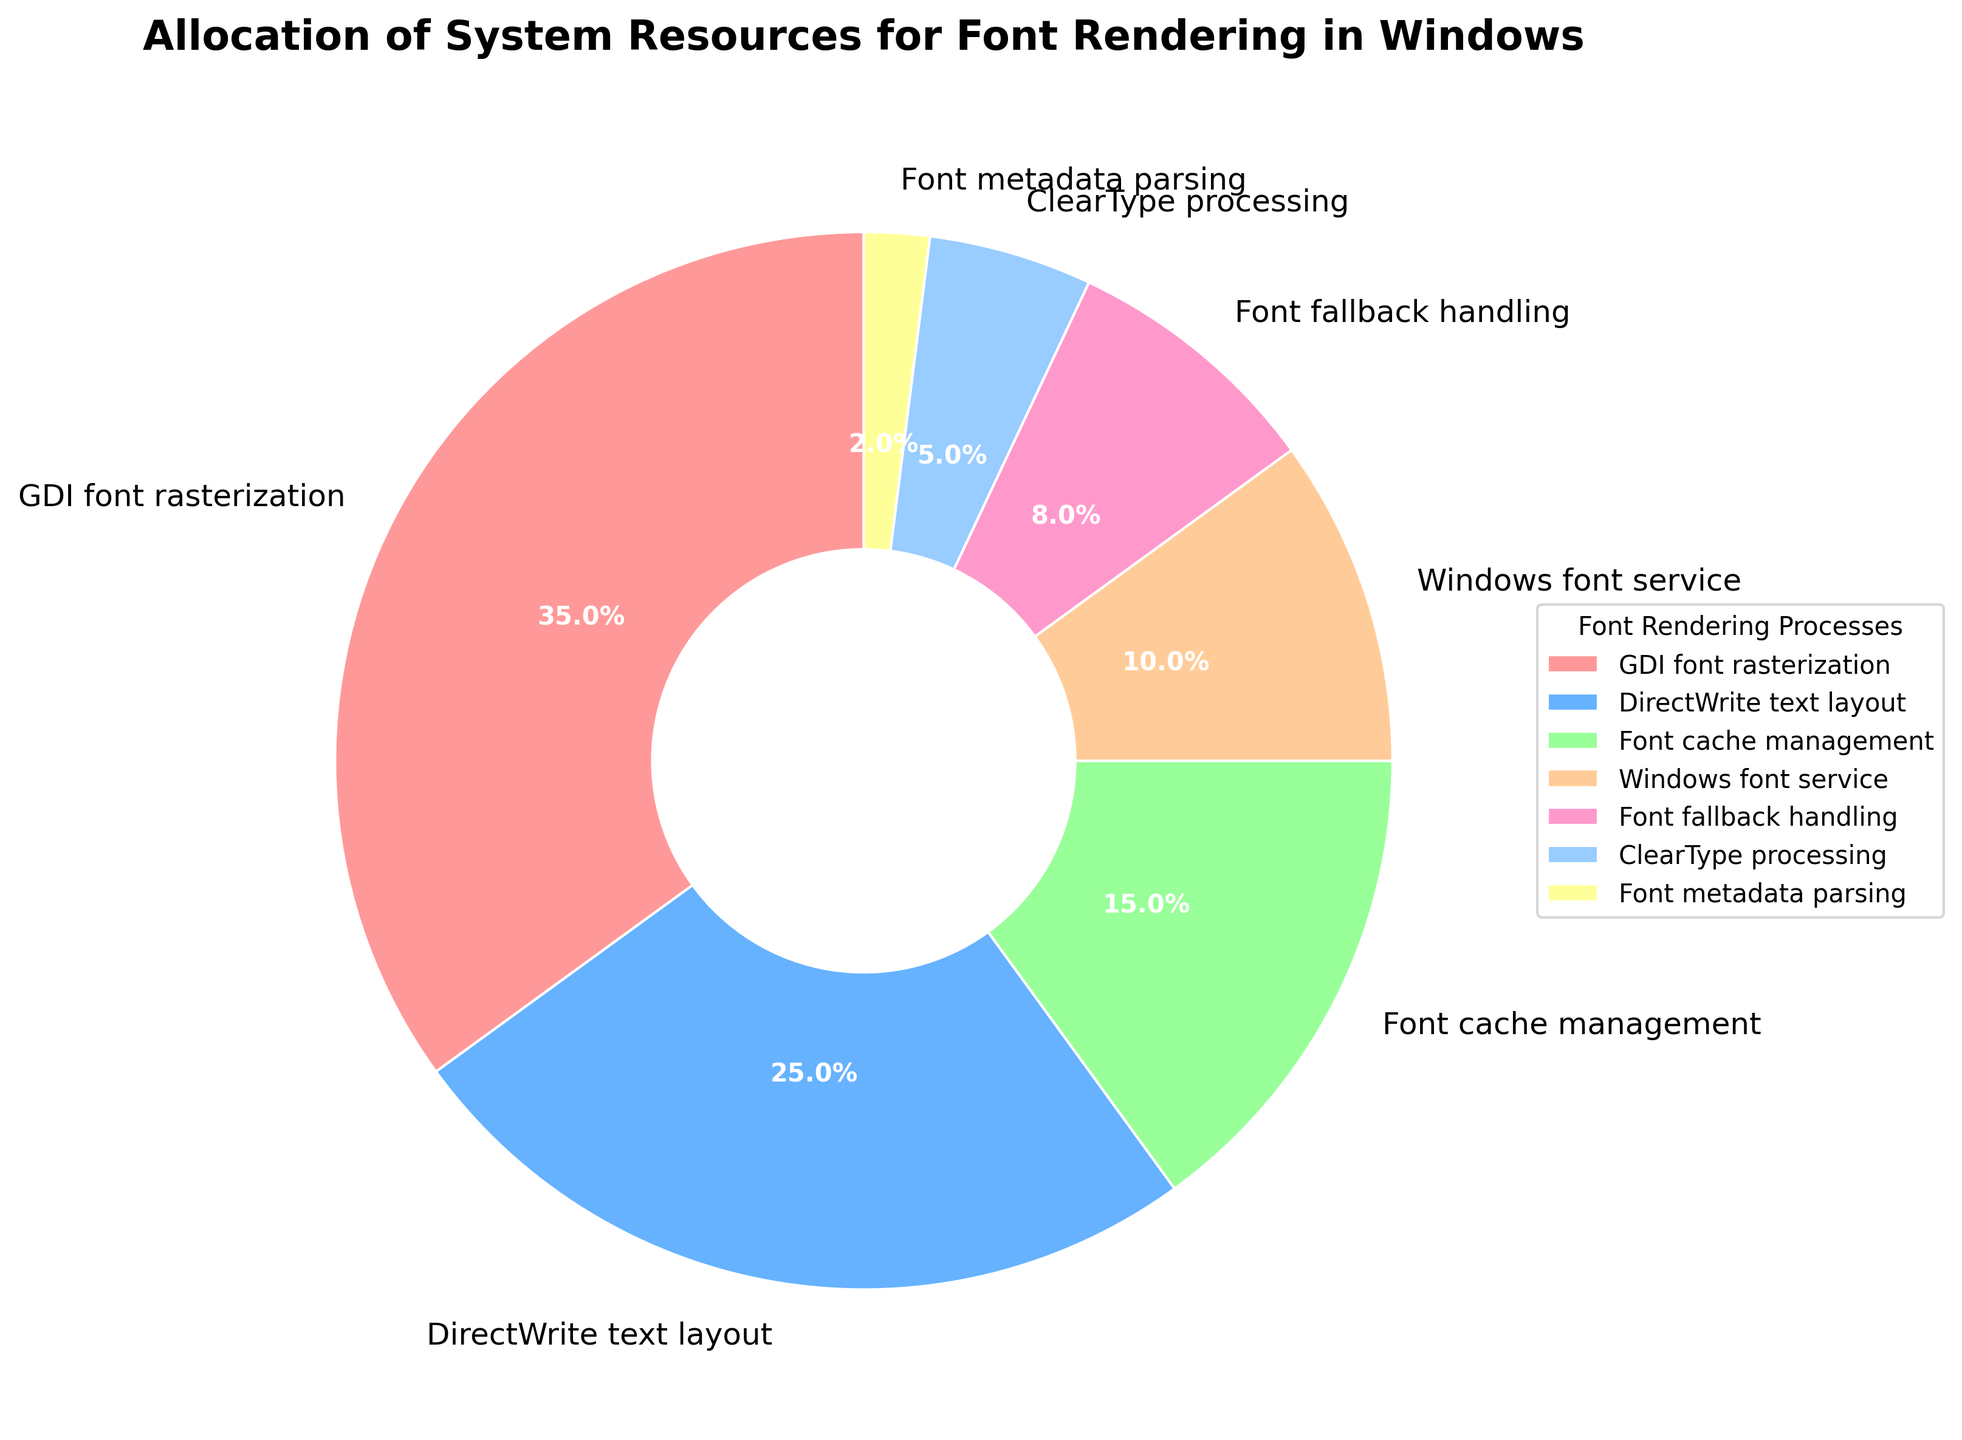What percentage of system resources is allocated to GDI font rasterization? GDI font rasterization is a segment in the pie chart. From the chart, it's clearly labeled with its percentage allocation.
Answer: 35% What combined percentage of resources is allocated to Font cache management and ClearType processing? First, identify the percentages of both Font cache management and ClearType processing from the chart. Then, add them together: 15% (Font cache management) + 5% (ClearType processing).
Answer: 20% Which font rendering process uses the least system resources? Identify the process with the smallest segment in the pie chart. The smallest segment is clearly labeled as Font metadata parsing.
Answer: Font metadata parsing Is the percentage of resources allocated to DirectWrite text layout greater than or less than 30%? Identify the percentage of DirectWrite text layout from the pie chart. It is labeled as 25%, which is less than 30%.
Answer: Less than 30% Compare the percentage of resources allocated to Font fallback handling and Windows font service. Which one has a higher percentage? Identify the percentages for both Font fallback handling (8%) and Windows font service (10%) from the pie chart. Windows font service (10%) is higher than Font fallback handling (8%).
Answer: Windows font service What is the combined percentage of resources allocated to processes other than GDI font rasterization? Subtract the percentage for GDI font rasterization from 100%: 100% - 35% = 65%.
Answer: 65% What percentage of system resources does the largest segment of the pie chart represent? The largest segment of the pie chart is labeled for GDI font rasterization, which is 35%.
Answer: 35% How much more percentage is allocated to GDI font rasterization compared to Font cache management? Identify the percentages for both GDI font rasterization (35%) and Font cache management (15%). Subtract the smaller one from the larger one: 35% - 15% = 20%.
Answer: 20% Identify the processes that use more than 20% of the system resources. From the pie chart, identify which segments have percentages greater than 20%. The processes with over 20% are GDI font rasterization (35%) and DirectWrite text layout (25%).
Answer: GDI font rasterization, DirectWrite text layout 